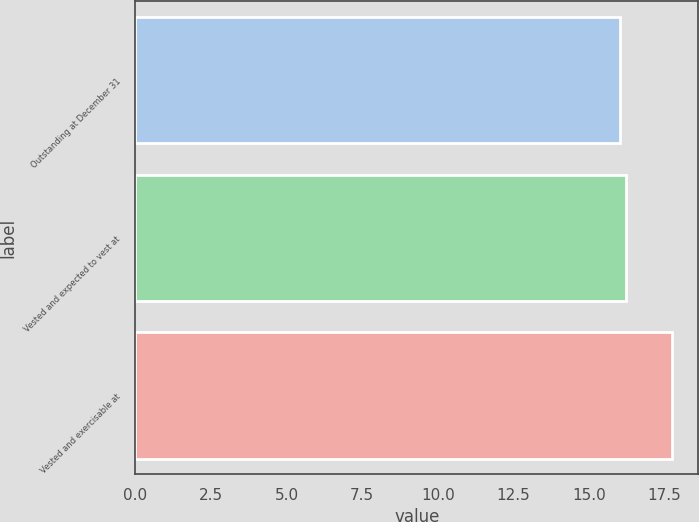<chart> <loc_0><loc_0><loc_500><loc_500><bar_chart><fcel>Outstanding at December 31<fcel>Vested and expected to vest at<fcel>Vested and exercisable at<nl><fcel>16.04<fcel>16.21<fcel>17.73<nl></chart> 